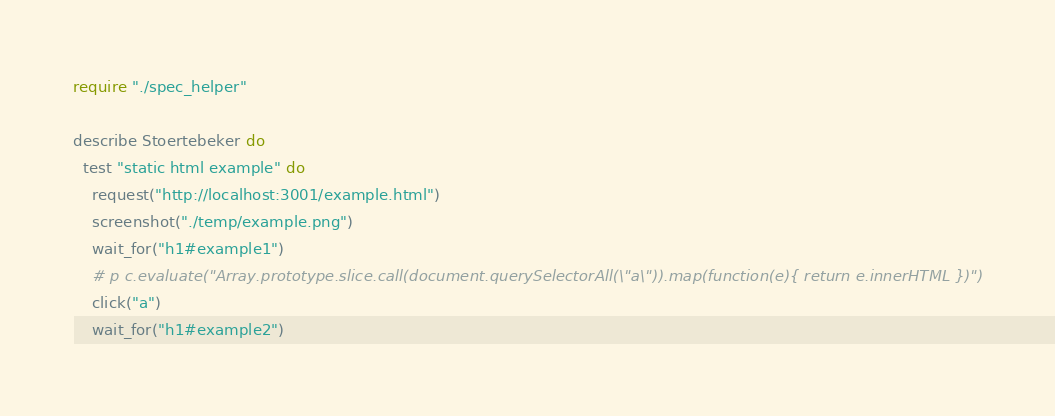<code> <loc_0><loc_0><loc_500><loc_500><_Crystal_>require "./spec_helper"

describe Stoertebeker do
  test "static html example" do
    request("http://localhost:3001/example.html")
    screenshot("./temp/example.png")
    wait_for("h1#example1")
    # p c.evaluate("Array.prototype.slice.call(document.querySelectorAll(\"a\")).map(function(e){ return e.innerHTML })")
    click("a")
    wait_for("h1#example2")</code> 